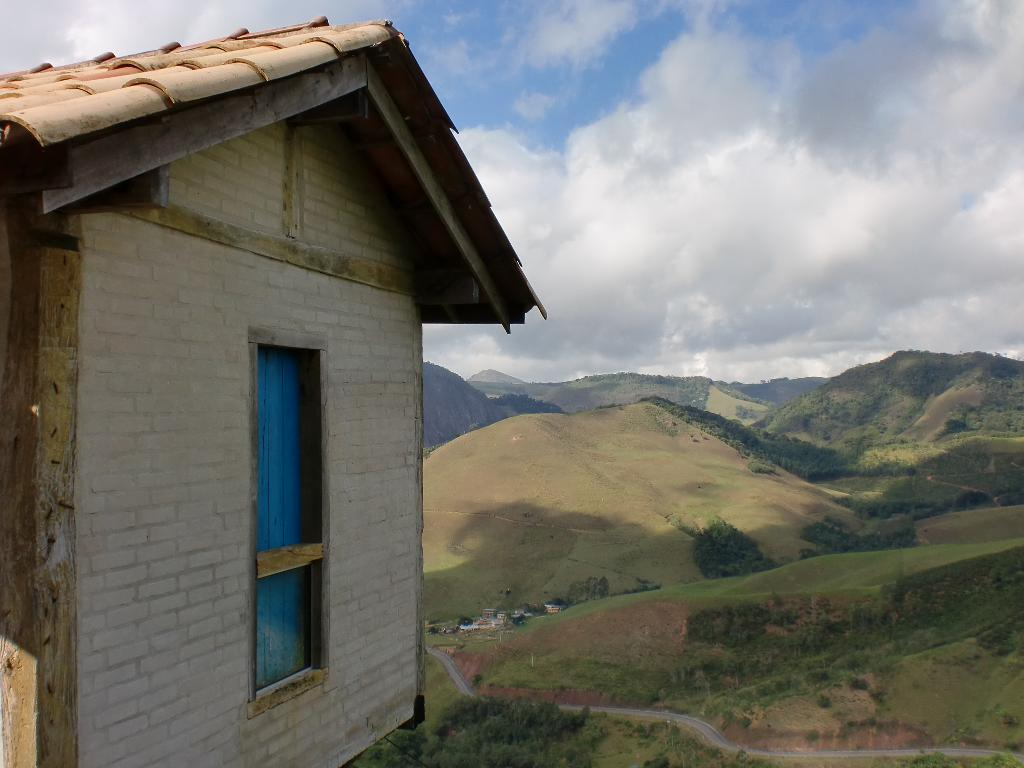What type of structure is present in the image? There is a house in the image. What is located behind the house? There is a road behind the house. What type of vegetation can be seen in the image? There are trees visible in the image. What geographical features are present in the background? There are hills in the background. How would you describe the weather based on the image? The sky is cloudy in the image. Where is the shop located in the image? There is no shop present in the image. Can you describe the fight happening between the frogs in the image? There are no frogs or fights depicted in the image. 